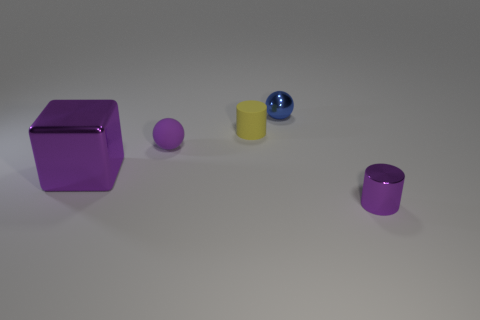Do the cylinder that is to the right of the blue shiny sphere and the tiny metal object that is behind the shiny cylinder have the same color? Indeed, both the cylinder to the right of the blue shiny sphere and the tiny metal object behind the shiny cylinder are rendered in shades of purple. Although lighting may affect the perception of their colors slightly, they share the same base hue. 